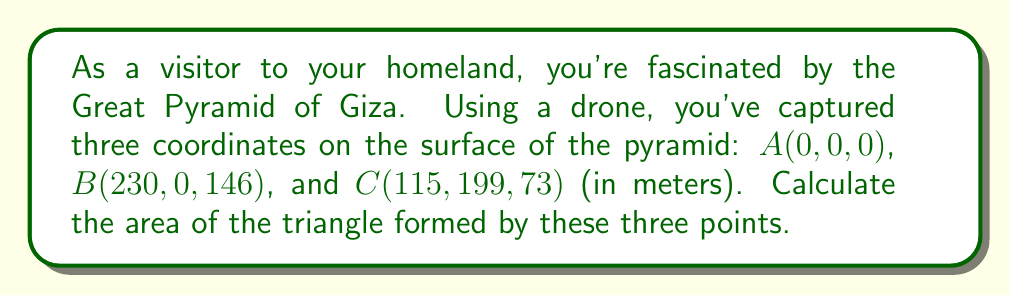Give your solution to this math problem. To find the area of a triangle in 3D space, we can use the formula:

$$\text{Area} = \frac{1}{2}|\vec{AB} \times \vec{AC}|$$

Where $\vec{AB}$ and $\vec{AC}$ are vectors, and $\times$ denotes the cross product.

Step 1: Calculate vectors $\vec{AB}$ and $\vec{AC}$
$\vec{AB} = B - A = (230-0, 0-0, 146-0) = (230, 0, 146)$
$\vec{AC} = C - A = (115-0, 199-0, 73-0) = (115, 199, 73)$

Step 2: Calculate the cross product $\vec{AB} \times \vec{AC}$
$$\vec{AB} \times \vec{AC} = \begin{vmatrix}
i & j & k \\
230 & 0 & 146 \\
115 & 199 & 73
\end{vmatrix}$$

$= (0 \cdot 73 - 146 \cdot 199)i + (230 \cdot 73 - 146 \cdot 115)j + (230 \cdot 199 - 0 \cdot 115)k$
$= -29054i + 828j + 45770k$

Step 3: Calculate the magnitude of the cross product
$|\vec{AB} \times \vec{AC}| = \sqrt{(-29054)^2 + 828^2 + 45770^2}$
$= \sqrt{844135316 + 685584 + 2094892900}$
$= \sqrt{2939713800}$
$= 54219.15$ (rounded to 2 decimal places)

Step 4: Calculate the area
Area $= \frac{1}{2} \cdot 54219.15 = 27109.58$ square meters

[asy]
import three;

currentprojection=perspective(6,3,2);
triple A=(0,0,0), B=(230,0,146), C=(115,199,73);

draw(A--B--C--cycle);
dot("A",A,N);
dot("B",B,E);
dot("C",C,NW);

draw(O--230X,dashed);
draw(O--199Y,dashed);
draw(O--146Z,dashed);
[/asy]
Answer: The area of the triangle is approximately 27109.58 square meters. 